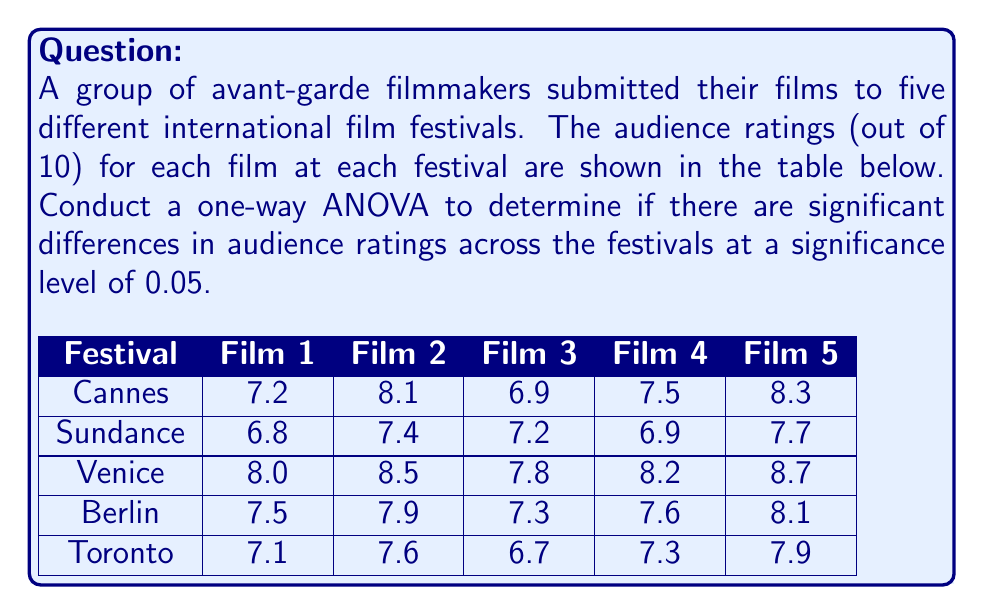Can you answer this question? To conduct a one-way ANOVA, we'll follow these steps:

1) Calculate the mean for each festival and the overall mean:
   Cannes: $\bar{x}_1 = 7.6$
   Sundance: $\bar{x}_2 = 7.2$
   Venice: $\bar{x}_3 = 8.24$
   Berlin: $\bar{x}_4 = 7.68$
   Toronto: $\bar{x}_5 = 7.32$
   Overall mean: $\bar{x} = 7.608$

2) Calculate the Sum of Squares Between (SSB):
   $$SSB = \sum_{i=1}^k n_i(\bar{x}_i - \bar{x})^2$$
   where $k = 5$ (number of festivals) and $n_i = 5$ (number of films per festival)
   $$SSB = 5[(7.6 - 7.608)^2 + (7.2 - 7.608)^2 + (8.24 - 7.608)^2 + (7.68 - 7.608)^2 + (7.32 - 7.608)^2]$$
   $$SSB = 3.2672$$

3) Calculate the Sum of Squares Within (SSW):
   $$SSW = \sum_{i=1}^k \sum_{j=1}^{n_i} (x_{ij} - \bar{x}_i)^2$$
   $$SSW = 2.456$$

4) Calculate the Sum of Squares Total (SST):
   $$SST = SSB + SSW = 3.2672 + 2.456 = 5.7232$$

5) Calculate the degrees of freedom:
   Between groups: $df_B = k - 1 = 4$
   Within groups: $df_W = N - k = 25 - 5 = 20$
   Total: $df_T = N - 1 = 24$

6) Calculate the Mean Squares:
   $$MS_B = \frac{SSB}{df_B} = \frac{3.2672}{4} = 0.8168$$
   $$MS_W = \frac{SSW}{df_W} = \frac{2.456}{20} = 0.1228$$

7) Calculate the F-statistic:
   $$F = \frac{MS_B}{MS_W} = \frac{0.8168}{0.1228} = 6.65$$

8) Find the critical F-value:
   For $\alpha = 0.05$, $df_B = 4$, and $df_W = 20$, the critical F-value is approximately 2.87.

9) Compare the F-statistic to the critical F-value:
   Since $6.65 > 2.87$, we reject the null hypothesis.
Answer: $F(4,20) = 6.65, p < 0.05$. Significant differences exist in audience ratings across festivals. 